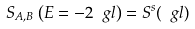Convert formula to latex. <formula><loc_0><loc_0><loc_500><loc_500>S _ { A , B } \left ( E = - 2 \ g l \right ) = S ^ { s } ( \ g l )</formula> 